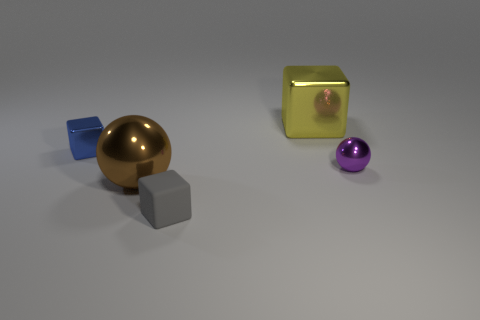Subtract all gray blocks. How many blocks are left? 2 Add 4 purple balls. How many objects exist? 9 Subtract all green spheres. How many green blocks are left? 0 Add 1 yellow things. How many yellow things are left? 2 Add 4 large purple things. How many large purple things exist? 4 Subtract all blue blocks. How many blocks are left? 2 Subtract 0 green blocks. How many objects are left? 5 Subtract all blocks. How many objects are left? 2 Subtract all gray spheres. Subtract all green cubes. How many spheres are left? 2 Subtract all large blue shiny spheres. Subtract all large brown spheres. How many objects are left? 4 